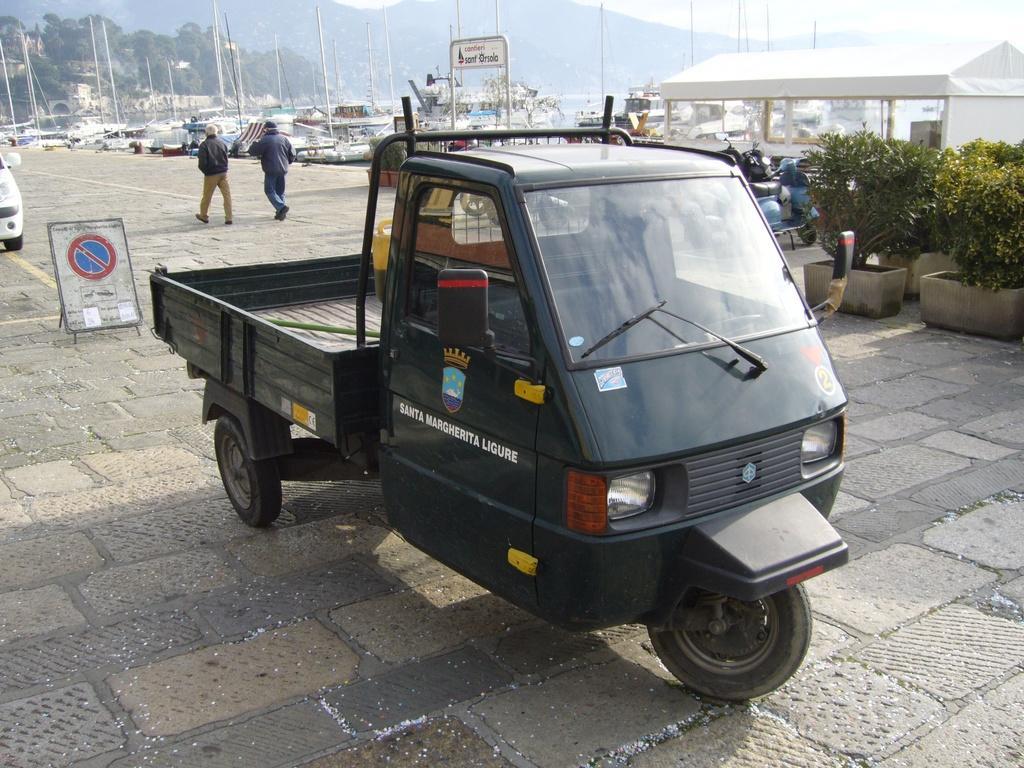In one or two sentences, can you explain what this image depicts? In this picture there are vehicles and there is a tent and there are plants in the foreground. At the back there are two persons walking on the pavement and there are boats on the water and there are buildings and trees and mountains. At the top there is sky. At the bottom there is water and pavement. 